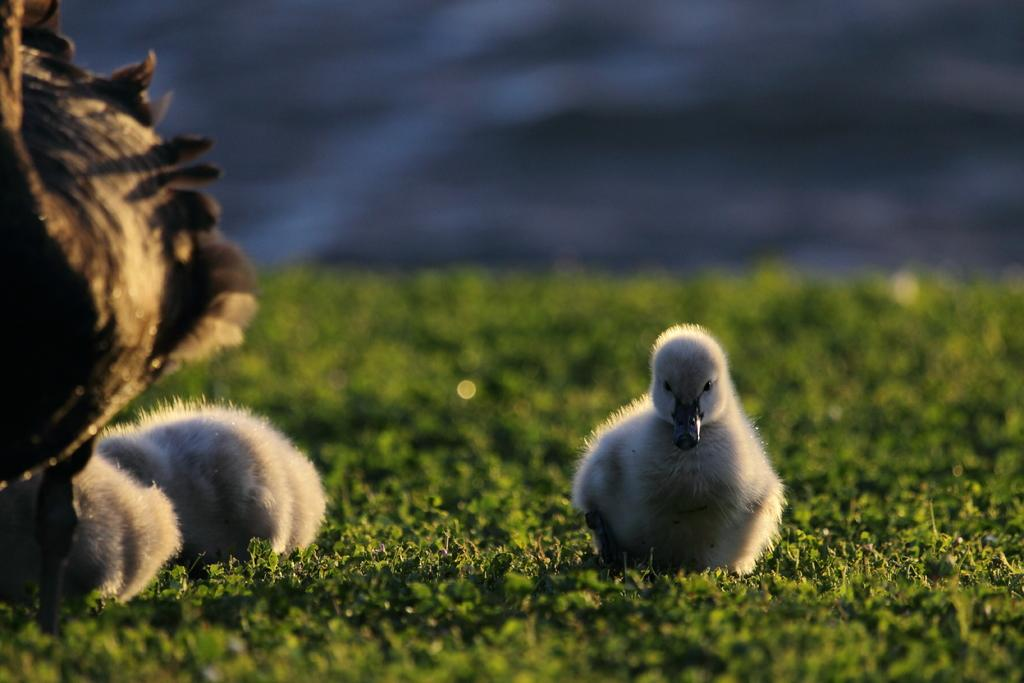What is the main subject in the center of the picture? There is a duckling in the center of the picture. What other animals are present on the left side of the picture? There are ducklings and a duck on the left side of the picture. What type of vegetation can be seen in the foreground of the picture? There is grass in the foreground of the picture. How would you describe the background of the picture? The background of the picture is blurred. How many spiders are crawling on the ducklings in the picture? There are no spiders present in the picture; it features ducklings and a duck. What type of crib is visible in the background of the picture? There is no crib present in the picture; the background is blurred and does not show any furniture or objects. 